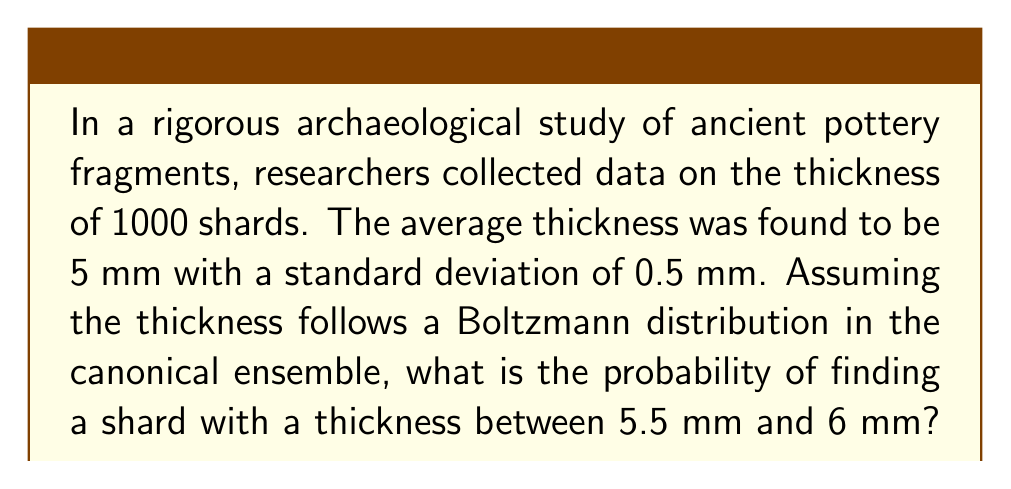What is the answer to this math problem? To solve this problem, we'll use the canonical ensemble and the Boltzmann distribution. Let's approach this step-by-step:

1) The Boltzmann distribution in the canonical ensemble is given by:

   $$P(E) = \frac{1}{Z} e^{-\beta E}$$

   where $Z$ is the partition function, $\beta = \frac{1}{k_B T}$, and $E$ is the energy (in our case, thickness).

2) For a Gaussian distribution (which we can assume here due to the Central Limit Theorem), we can relate the standard deviation $\sigma$ to $\beta$:

   $$\sigma^2 = \frac{1}{\beta}$$

3) Given $\sigma = 0.5$ mm, we can calculate $\beta$:

   $$\beta = \frac{1}{\sigma^2} = \frac{1}{(0.5 \text{ mm})^2} = 4 \text{ mm}^{-2}$$

4) The probability density function for the Gaussian distribution is:

   $$P(x) = \frac{1}{\sigma \sqrt{2\pi}} e^{-\frac{(x-\mu)^2}{2\sigma^2}}$$

   where $\mu$ is the mean (5 mm in this case).

5) To find the probability between 5.5 mm and 6 mm, we need to integrate this function:

   $$P(5.5 \leq x \leq 6) = \int_{5.5}^6 \frac{1}{0.5 \sqrt{2\pi}} e^{-\frac{(x-5)^2}{2(0.5)^2}} dx$$

6) This integral doesn't have a simple analytical solution. We can solve it numerically or use the error function (erf). Using the error function:

   $$P(5.5 \leq x \leq 6) = \frac{1}{2}\left[\text{erf}\left(\frac{6-5}{0.5\sqrt{2}}\right) - \text{erf}\left(\frac{5.5-5}{0.5\sqrt{2}}\right)\right]$$

7) Calculating this:

   $$P(5.5 \leq x \leq 6) = \frac{1}{2}[\text{erf}(1.414) - \text{erf}(0.707)] \approx 0.1359$$

Therefore, the probability of finding a shard with a thickness between 5.5 mm and 6 mm is approximately 0.1359 or 13.59%.
Answer: 0.1359 